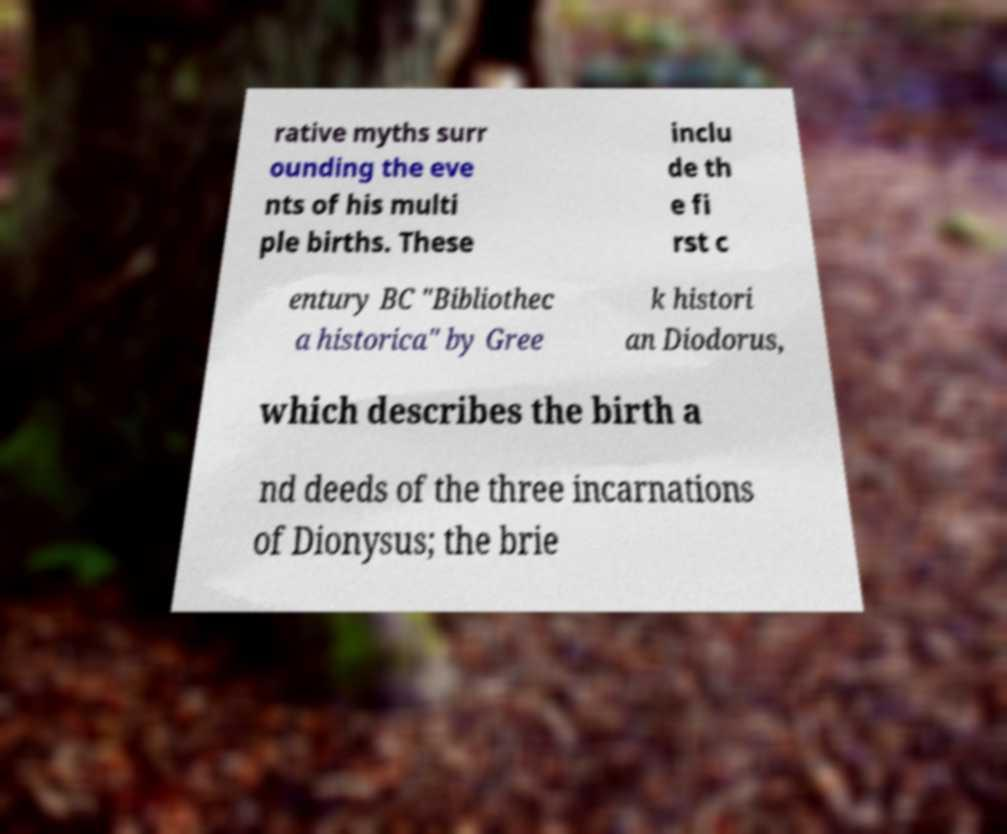There's text embedded in this image that I need extracted. Can you transcribe it verbatim? rative myths surr ounding the eve nts of his multi ple births. These inclu de th e fi rst c entury BC "Bibliothec a historica" by Gree k histori an Diodorus, which describes the birth a nd deeds of the three incarnations of Dionysus; the brie 